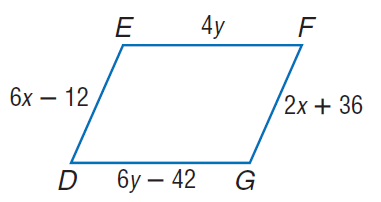Question: Find x so that the quadrilateral is a parallelogram.
Choices:
A. 12
B. 24
C. 60
D. 72
Answer with the letter. Answer: A Question: Find y so that the quadrilateral is a parallelogram.
Choices:
A. 21
B. 30
C. 42
D. 84
Answer with the letter. Answer: A 